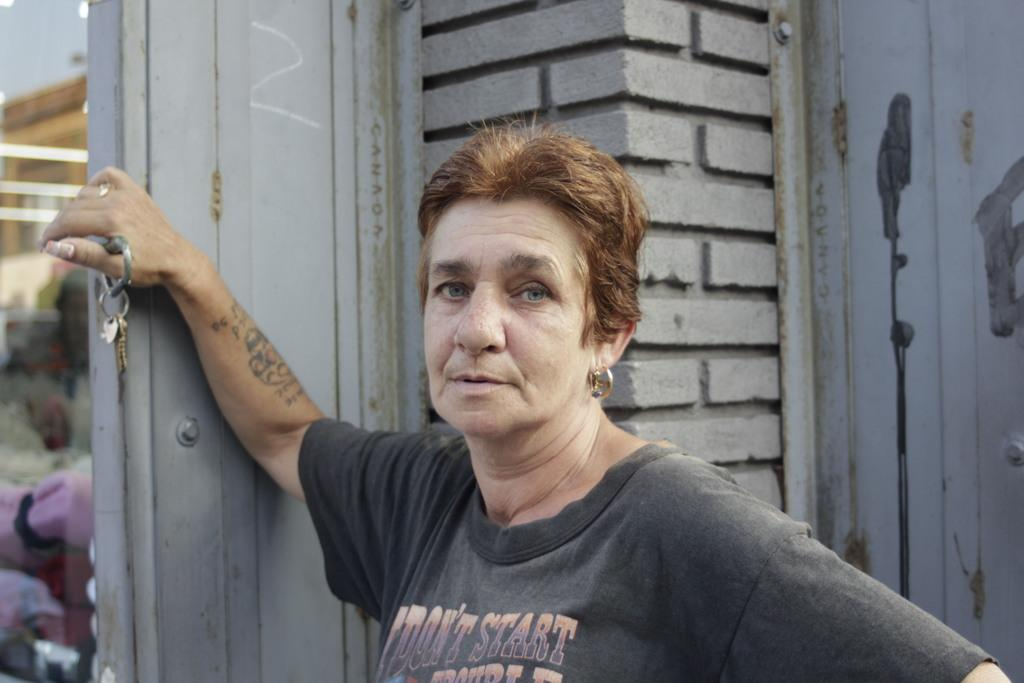What is the main subject of the image? There is a person standing in the image. What is the person holding in the image? The person is holding keys. What can be seen in the background of the image? There is an ash-colored wall visible in the image. What type of protest is taking place in the image? There is no protest present in the image; it only features a person standing and holding keys in front of an ash-colored wall. 